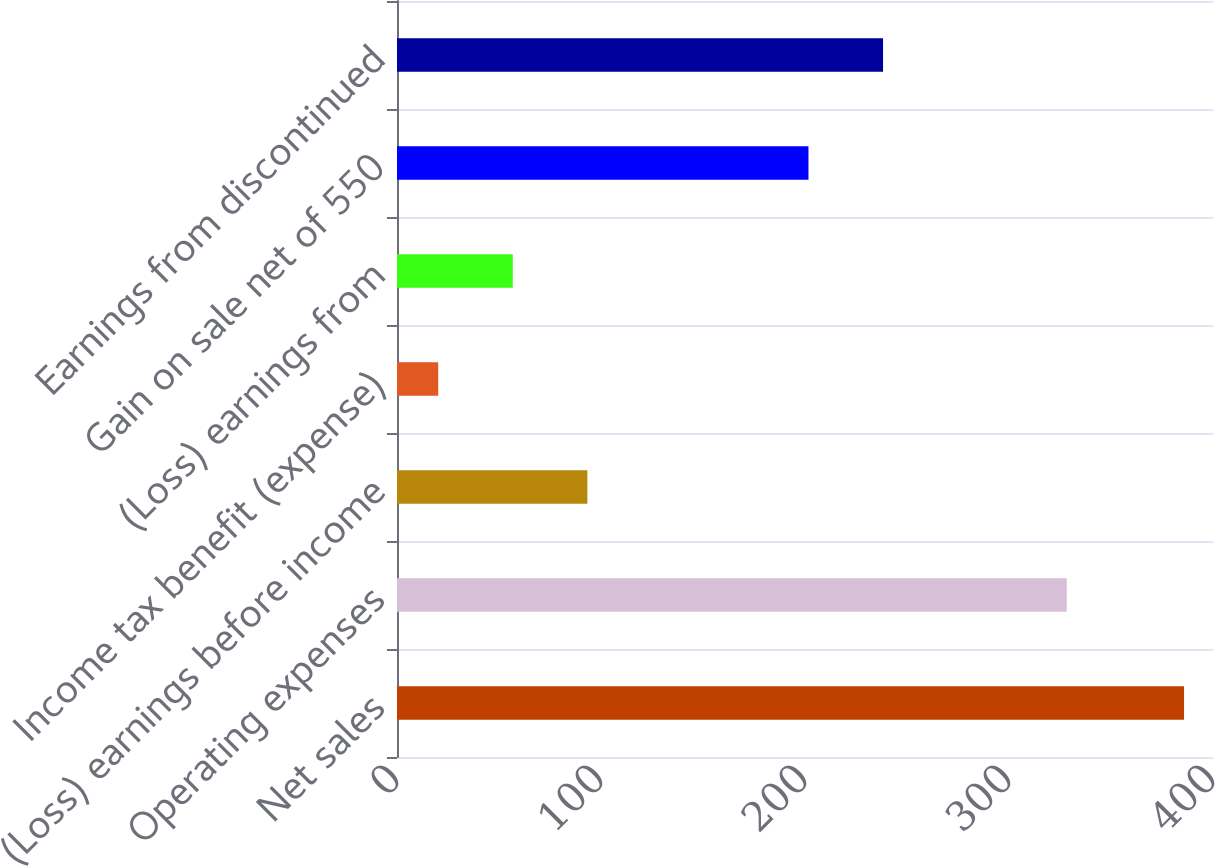Convert chart. <chart><loc_0><loc_0><loc_500><loc_500><bar_chart><fcel>Net sales<fcel>Operating expenses<fcel>(Loss) earnings before income<fcel>Income tax benefit (expense)<fcel>(Loss) earnings from<fcel>Gain on sale net of 550<fcel>Earnings from discontinued<nl><fcel>385.8<fcel>328.3<fcel>93.32<fcel>20.2<fcel>56.76<fcel>201.7<fcel>238.26<nl></chart> 